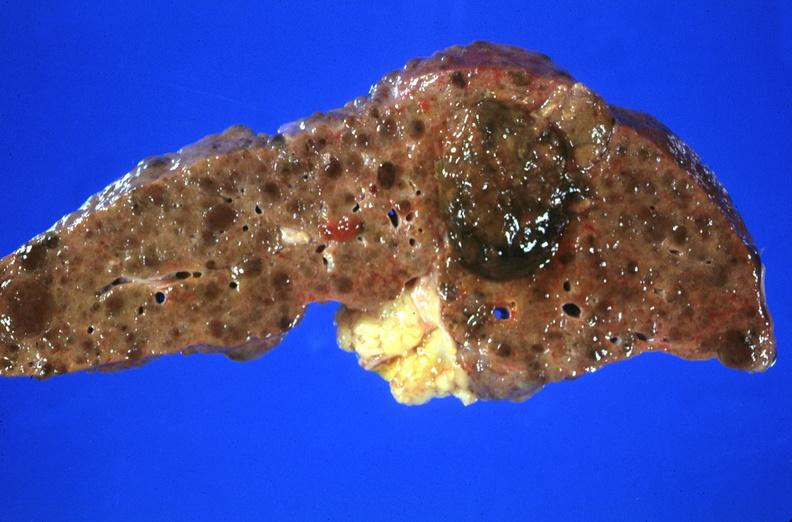what is present?
Answer the question using a single word or phrase. Liver 